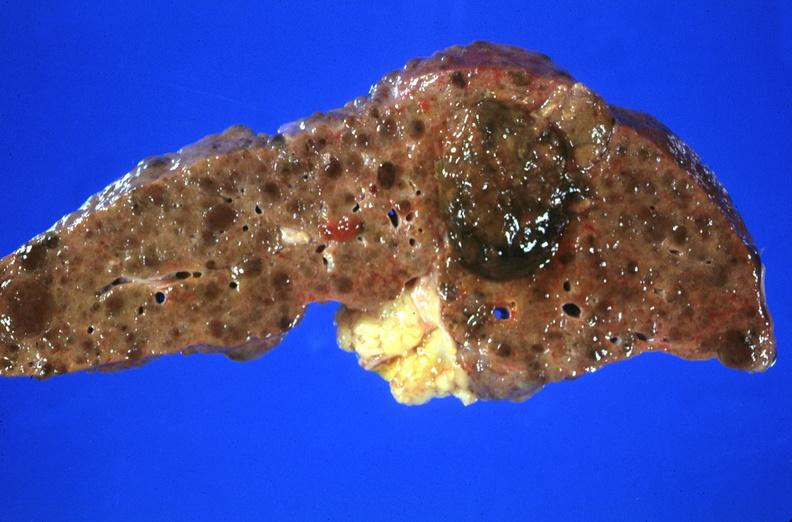what is present?
Answer the question using a single word or phrase. Liver 